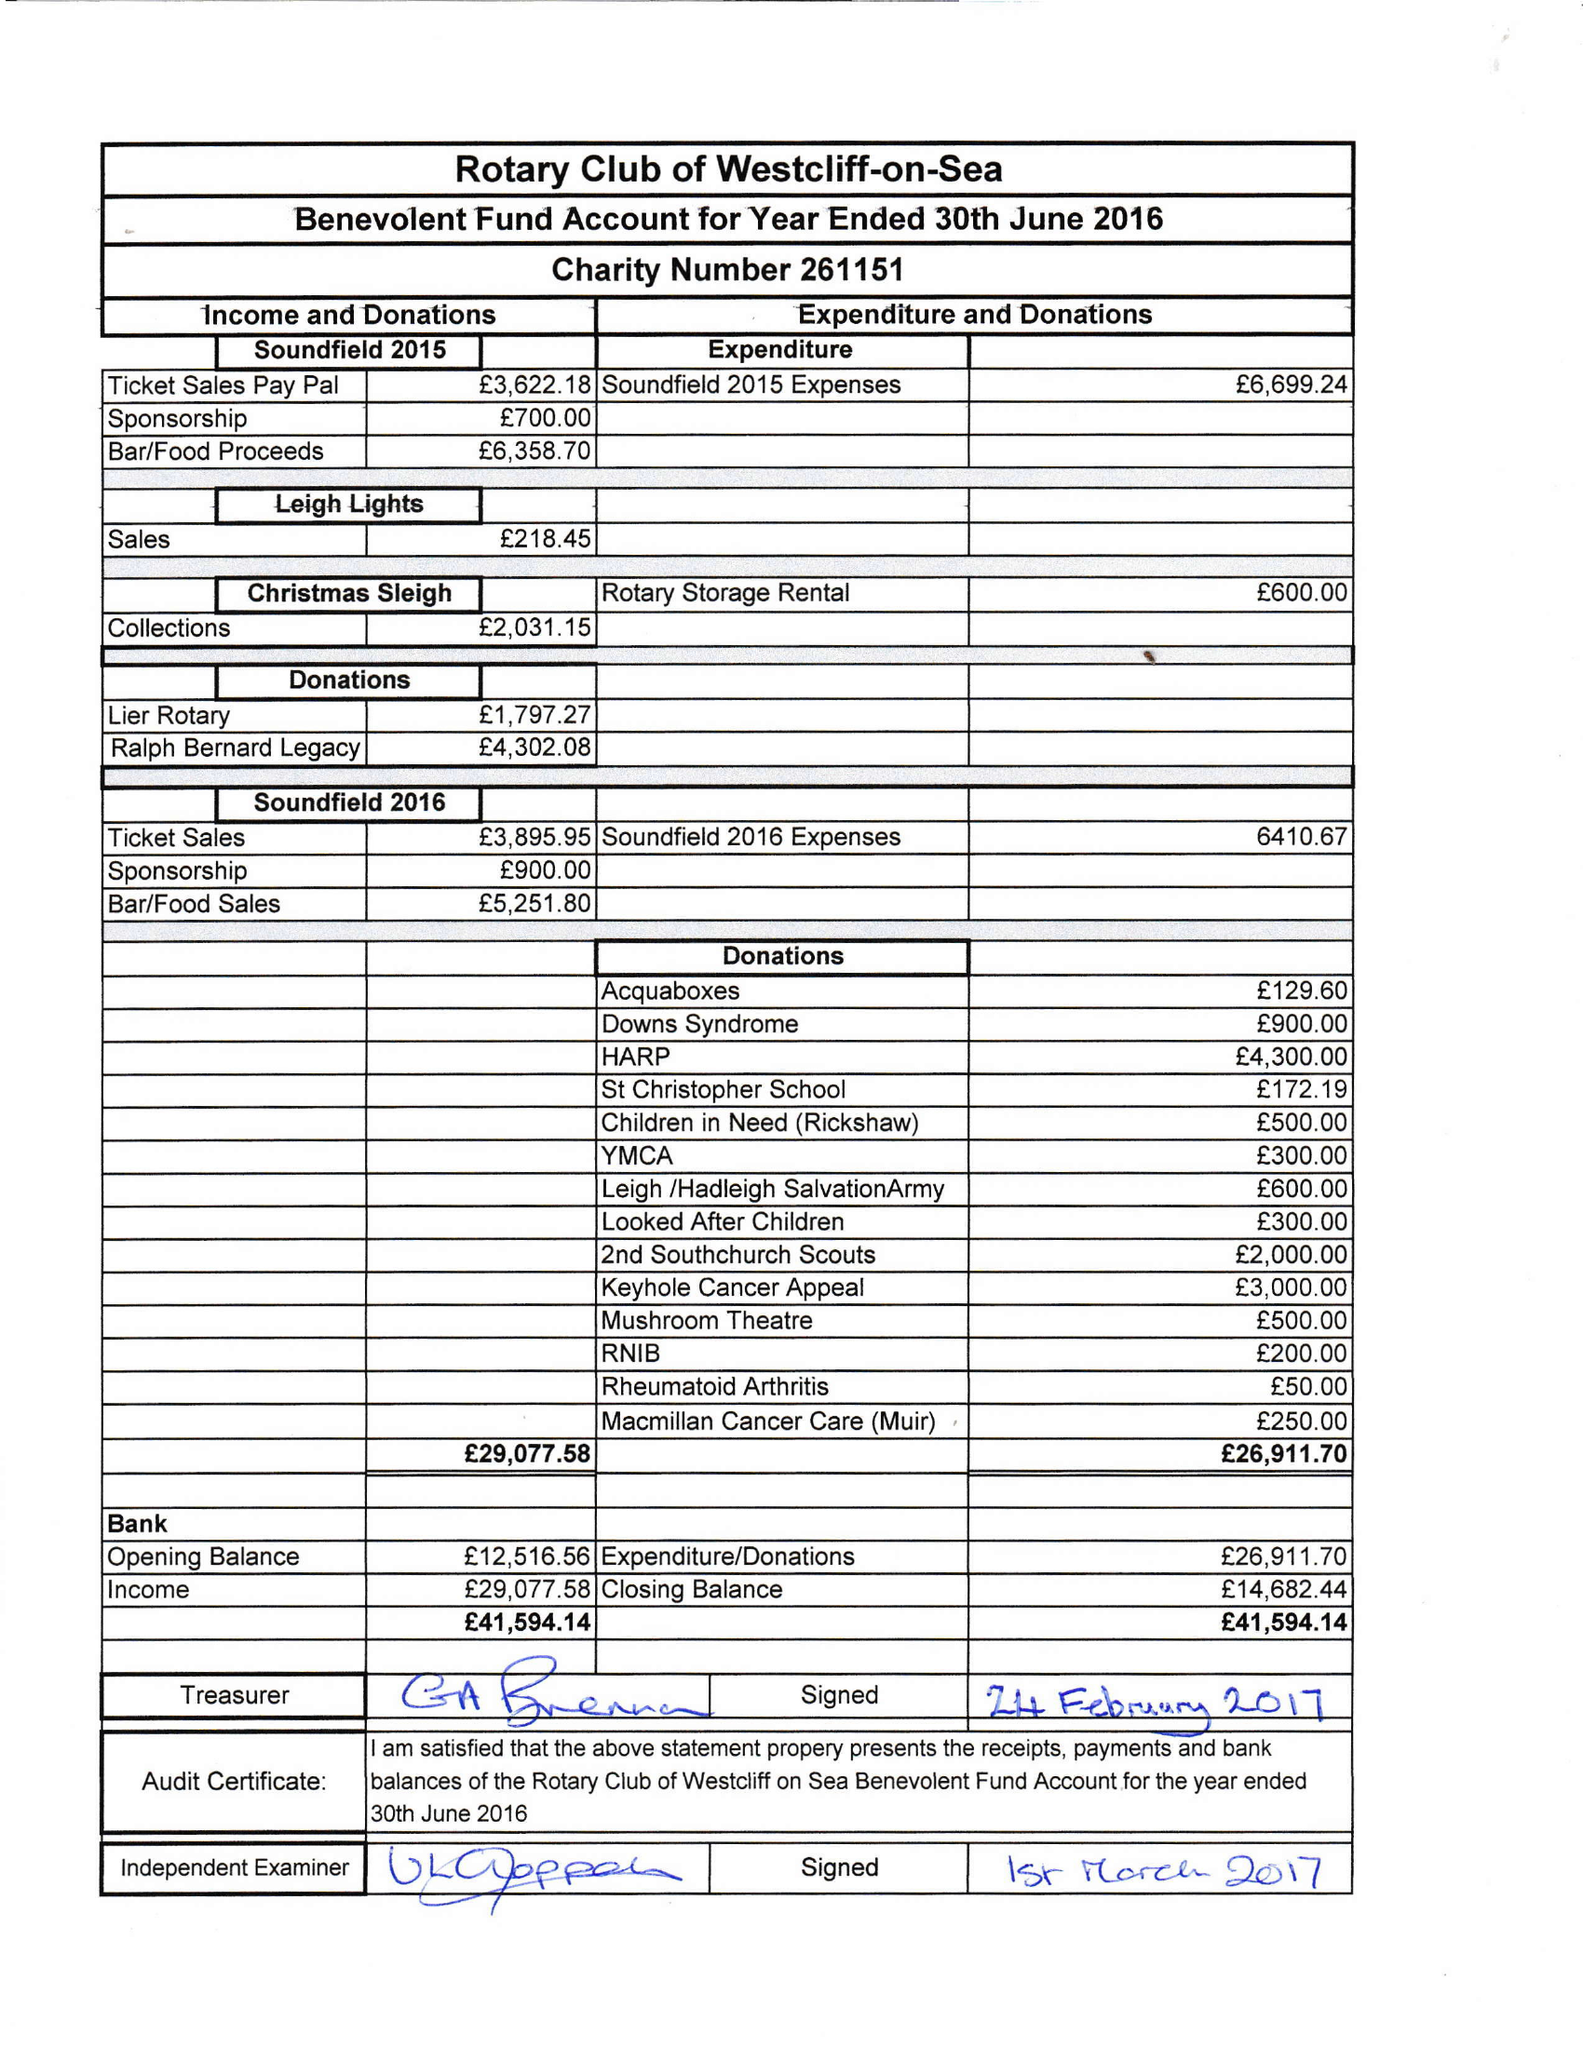What is the value for the spending_annually_in_british_pounds?
Answer the question using a single word or phrase. 26912.00 